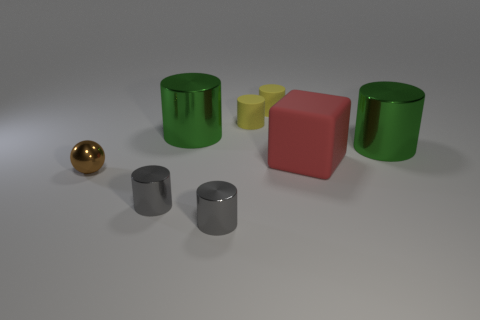There is a big object to the right of the large red rubber cube; is its shape the same as the red rubber thing?
Offer a very short reply. No. How many objects are either big cylinders that are on the right side of the big red block or small objects behind the tiny brown metal object?
Ensure brevity in your answer.  3. Is the number of small brown spheres to the right of the small brown metallic thing the same as the number of red matte cubes right of the rubber cube?
Keep it short and to the point. Yes. There is a big thing that is left of the large red rubber cube; what is its color?
Provide a succinct answer. Green. There is a sphere; is it the same color as the cylinder right of the red rubber thing?
Make the answer very short. No. Is the number of large yellow shiny cylinders less than the number of tiny yellow things?
Your answer should be very brief. Yes. Is the color of the cylinder right of the red matte thing the same as the large rubber cube?
Your answer should be compact. No. What number of rubber things are the same size as the block?
Your response must be concise. 0. Is there a tiny shiny sphere that has the same color as the large cube?
Your answer should be very brief. No. Are the small brown thing and the cube made of the same material?
Offer a terse response. No. 